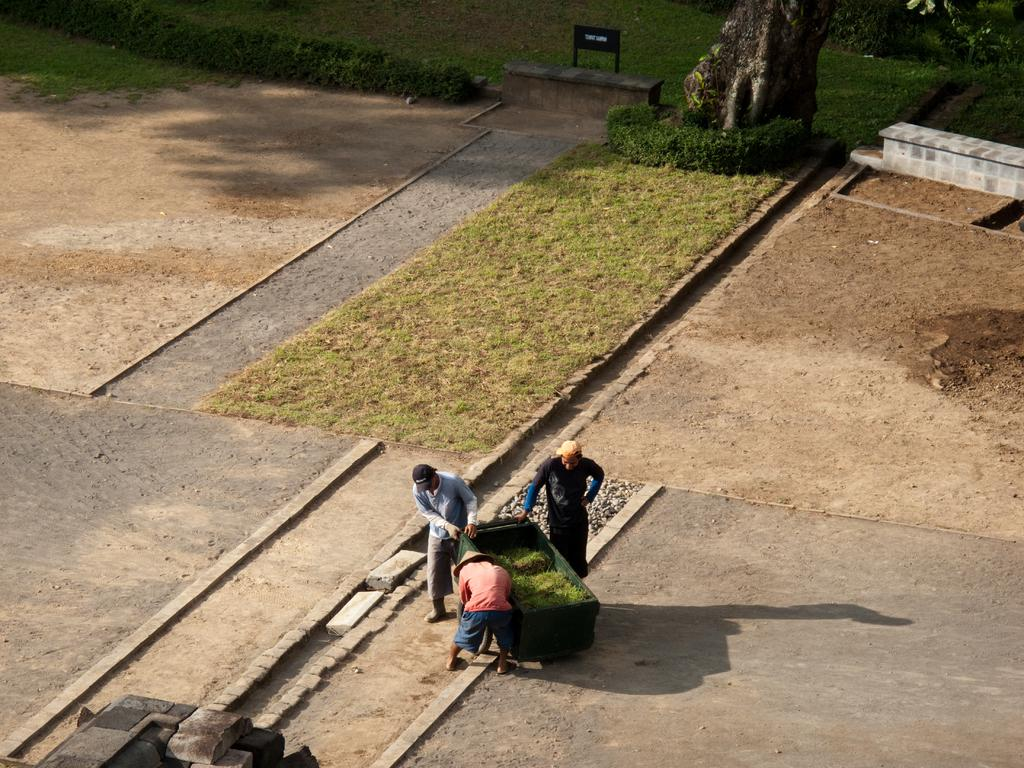What are the people in the image holding? The people in the image are holding an object. What type of natural elements can be seen in the image? There are trees and plants visible in the image. What is the surface on which the people are standing? The ground is visible in the image. What additional structure can be seen in the image? There is a board in the image. Can you see a kitten taking a bath in the image? There is no kitten or bath present in the image. 